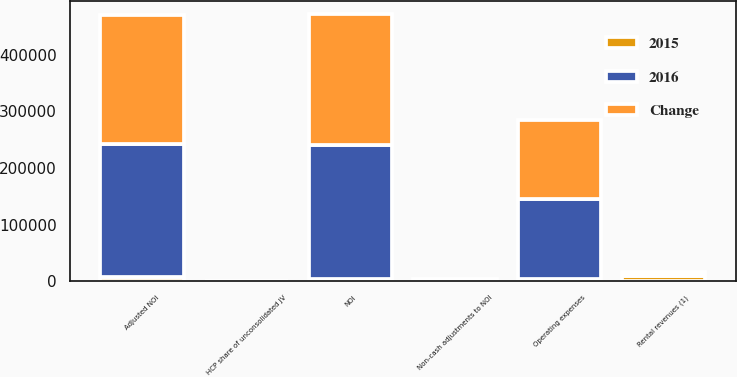Convert chart to OTSL. <chart><loc_0><loc_0><loc_500><loc_500><stacked_bar_chart><ecel><fcel>Rental revenues (1)<fcel>HCP share of unconsolidated JV<fcel>Operating expenses<fcel>NOI<fcel>Non-cash adjustments to NOI<fcel>Adjusted NOI<nl><fcel>2016<fcel>3767<fcel>595<fcel>141897<fcel>235730<fcel>463<fcel>235267<nl><fcel>Change<fcel>3767<fcel>612<fcel>138130<fcel>230896<fcel>2381<fcel>228515<nl><fcel>2015<fcel>8542<fcel>17<fcel>3767<fcel>4834<fcel>1918<fcel>6752<nl></chart> 